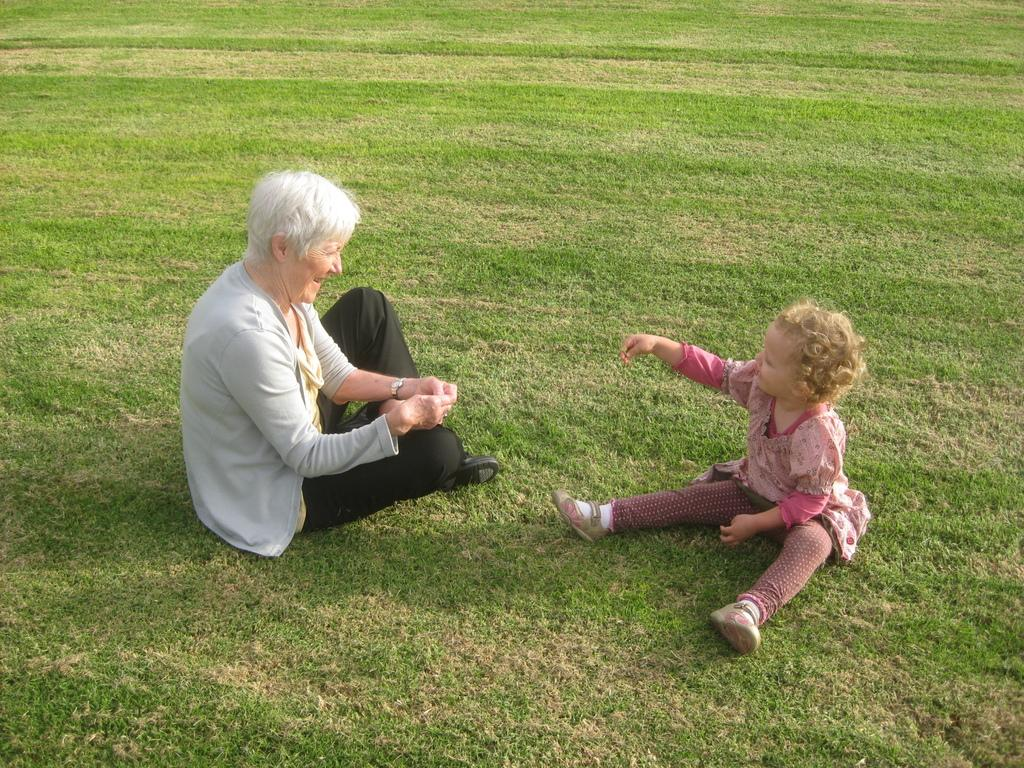Who is present in the image? There is a woman and a kid in the image. What are they doing in the image? Both the woman and the kid are sitting on the grass. What is the woman's emotional state in the image? The woman is laughing. What are the woman and the kid doing with their gaze? The woman and the kid are looking at each other. What type of fish can be seen swimming in the grass in the image? There are no fish present in the image, and fish cannot swim in grass. 